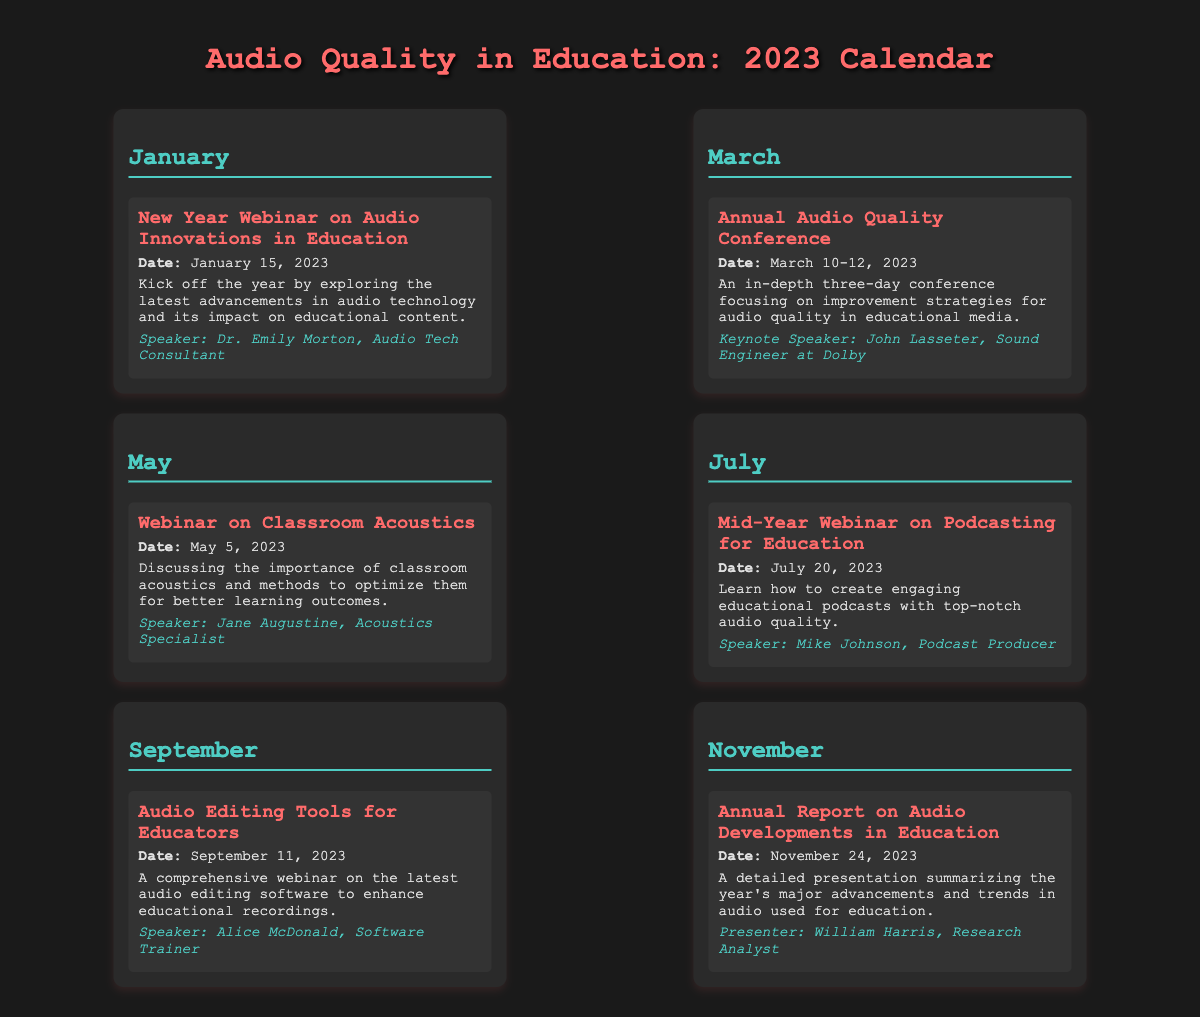What is the date of the New Year Webinar? The New Year Webinar is scheduled for January 15, 2023.
Answer: January 15, 2023 Who is the keynote speaker for the Annual Audio Quality Conference? The keynote speaker is John Lasseter, a Sound Engineer at Dolby.
Answer: John Lasseter What is the focus of the webinar on May 5, 2023? The May 5 webinar discusses the importance of classroom acoustics.
Answer: Classroom acoustics How many days does the Annual Audio Quality Conference last? The conference lasts for three days, from March 10 to March 12, 2023.
Answer: Three days Who presents the Annual Report on Audio Developments in Education? The presenter of the report is William Harris, a Research Analyst.
Answer: William Harris What is the title of the event scheduled for July 20, 2023? The event scheduled for July 20, 2023, is titled "Mid-Year Webinar on Podcasting for Education."
Answer: Mid-Year Webinar on Podcasting for Education What audio editing tools event occurs in September? The event is titled "Audio Editing Tools for Educators."
Answer: Audio Editing Tools for Educators Which professional speaks at the July webinar? The speaker at the July webinar is Mike Johnson, a Podcast Producer.
Answer: Mike Johnson 